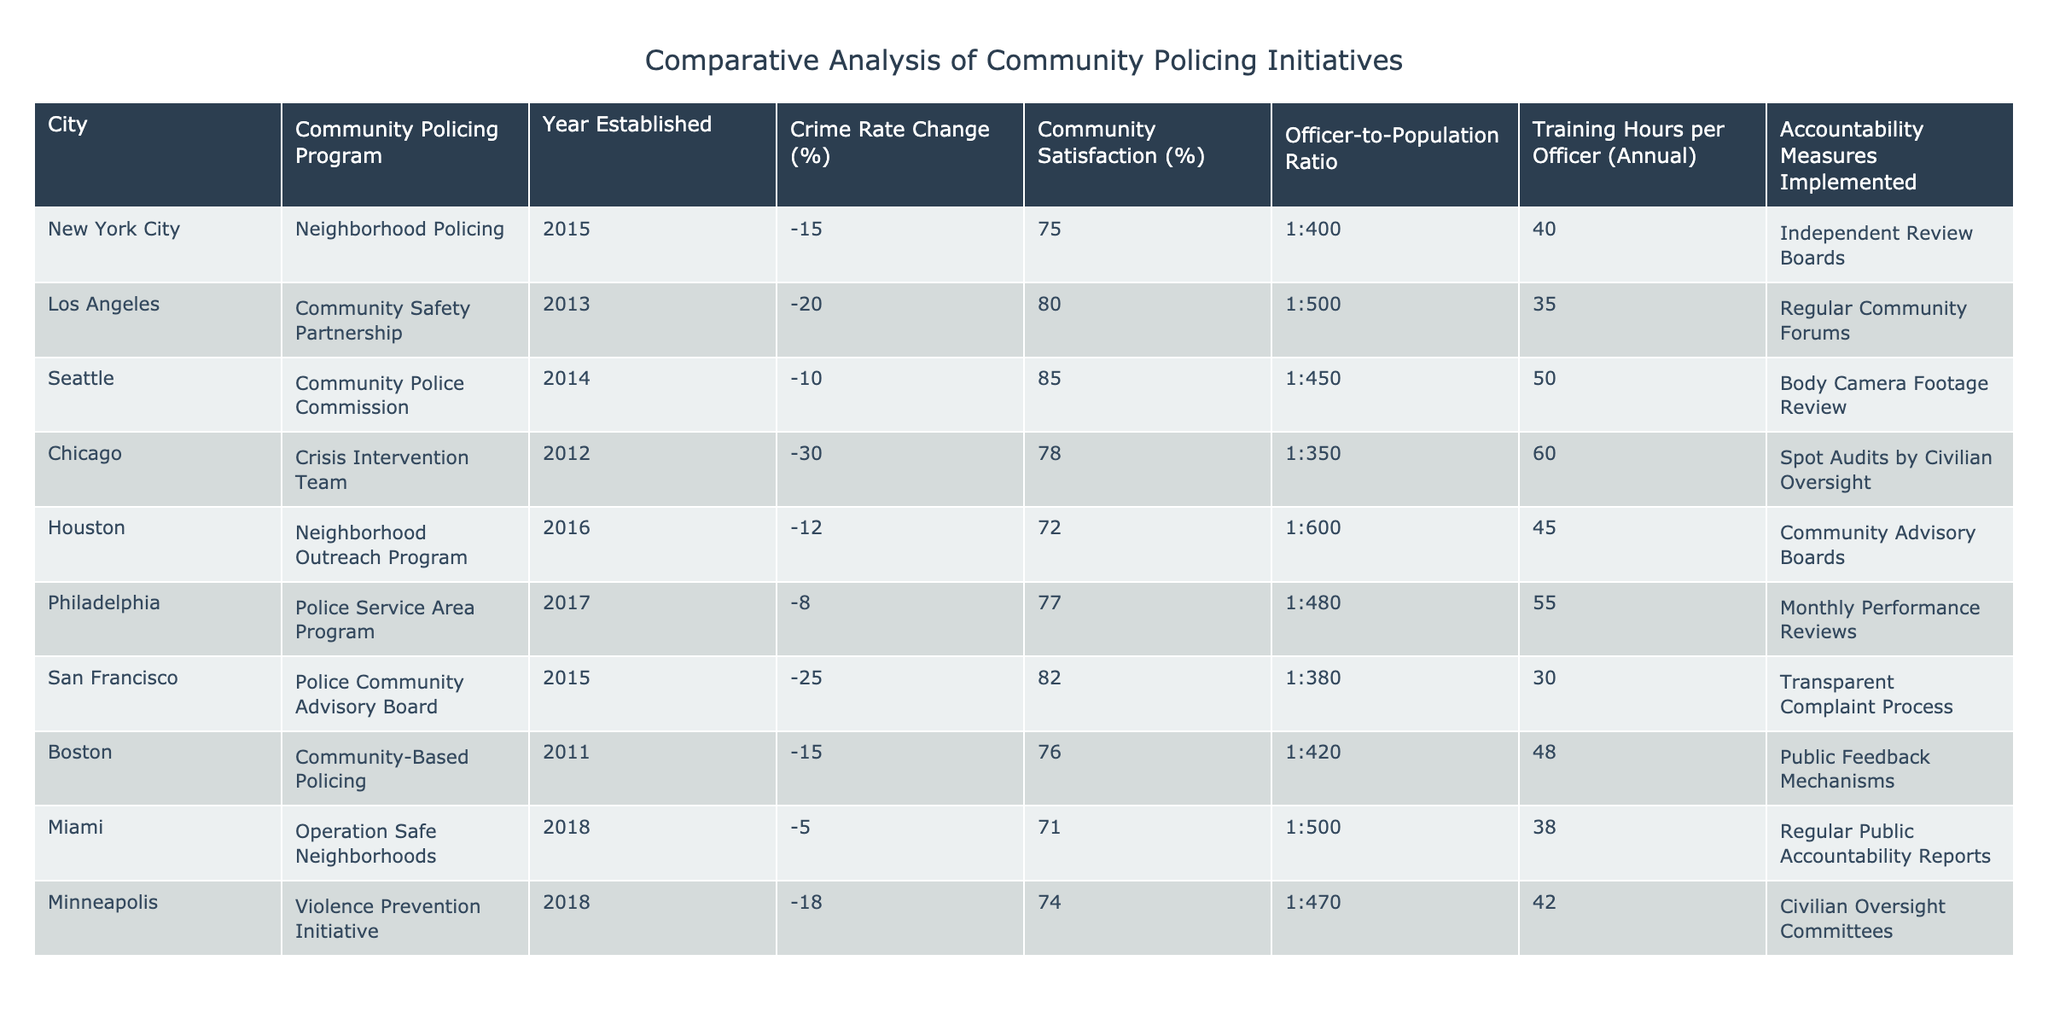What is the crime rate change in Los Angeles? The table lists the crime rate change for Los Angeles as -20%. Thus, the answer can be directly retrieved from the corresponding row for Los Angeles.
Answer: -20% Which city has the highest community satisfaction percentage? By examining the community satisfaction percentages, Seattle has the highest at 85%. This is determined by comparing each city's percentage from the table.
Answer: 85% What is the average officer-to-population ratio for the cities listed? The officer-to-population ratios for the cities are: 1:400, 1:500, 1:450, 1:350, 1:600, 1:480, 1:380, 1:500, and 1:470. Converting these ratios into a consistent format (e.g., total population per officer) gives: 400, 500, 450, 350, 600, 480, 380, 500, 470. The average is then calculated as (400 + 500 + 450 + 350 + 600 + 480 + 380 + 500 + 470) / 9 = 459.
Answer: 459 Did all cities implement accountability measures? A review of the table reveals that each city has an accountability measure implemented, confirming that the statement is true.
Answer: Yes Which community policing program was established most recently? By looking at the 'Year Established' column, Miami's community policing program, Operation Safe Neighborhoods, was established in 2018, which is the most recent date.
Answer: Operation Safe Neighborhoods What is the difference in community satisfaction percentage between Chicago and Houston? Chicago's community satisfaction is 78%, while Houston's is 72%. The difference is calculated by subtracting Houston's percentage from Chicago's: 78% - 72% = 6%. Therefore, the community satisfaction difference is 6%.
Answer: 6% Does San Francisco have the lowest crime rate change among the cities listed? The crime rate change percentages for the cities indicate that San Francisco has a crime rate change of -25%, which is the lowest compared to all other cities listed.
Answer: Yes What is the median number of training hours per officer across the cities? The training hours per officer are: 40, 35, 50, 60, 45, 55, 30, 38, and 42. Arranging these in order gives: 30, 35, 38, 40, 42, 45, 50, 55, 60. The median is the middle value in this ordered list, which is 42.
Answer: 42 Which city shows the highest crime rate change improvement compared to its established year? Analyzing each city's crime rate changes, Chicago shows the highest improvement with a -30% change from an earlier year (2012) compared to others. Therefore, Chicago has the highest improvement.
Answer: Chicago 